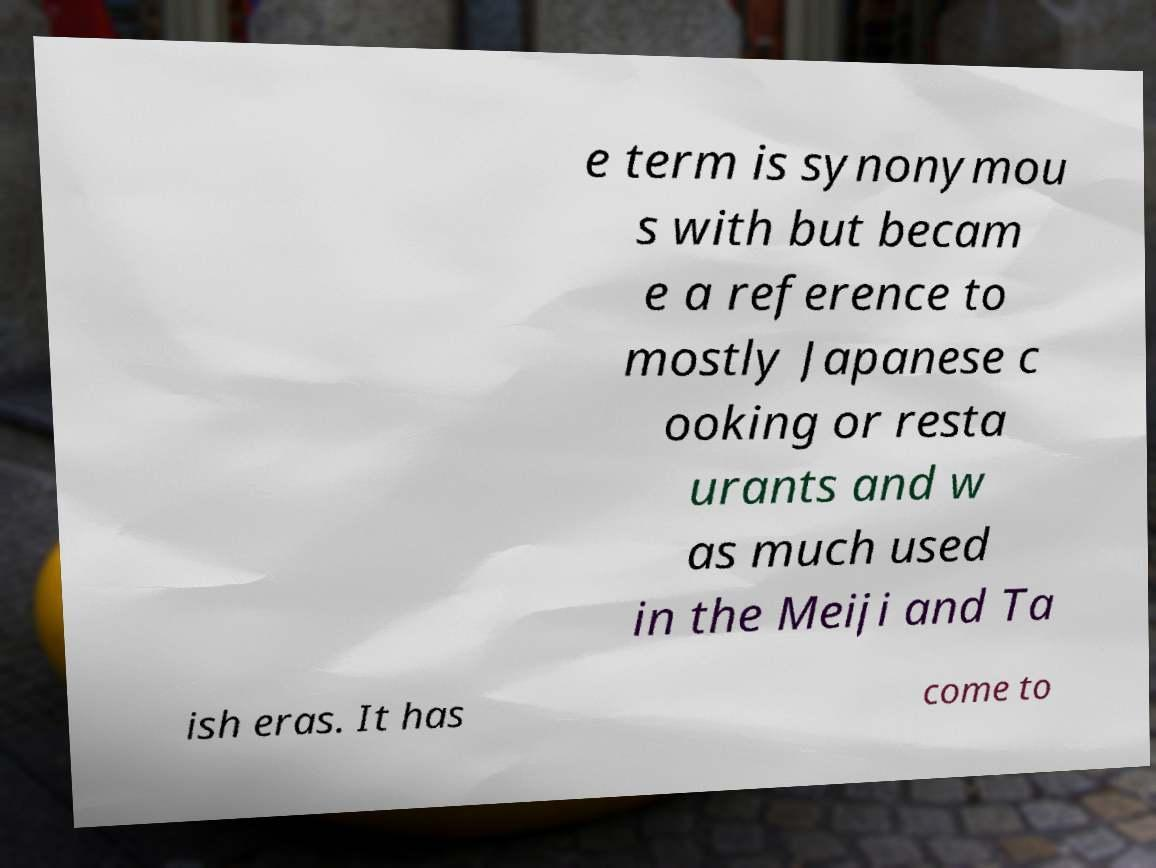There's text embedded in this image that I need extracted. Can you transcribe it verbatim? e term is synonymou s with but becam e a reference to mostly Japanese c ooking or resta urants and w as much used in the Meiji and Ta ish eras. It has come to 